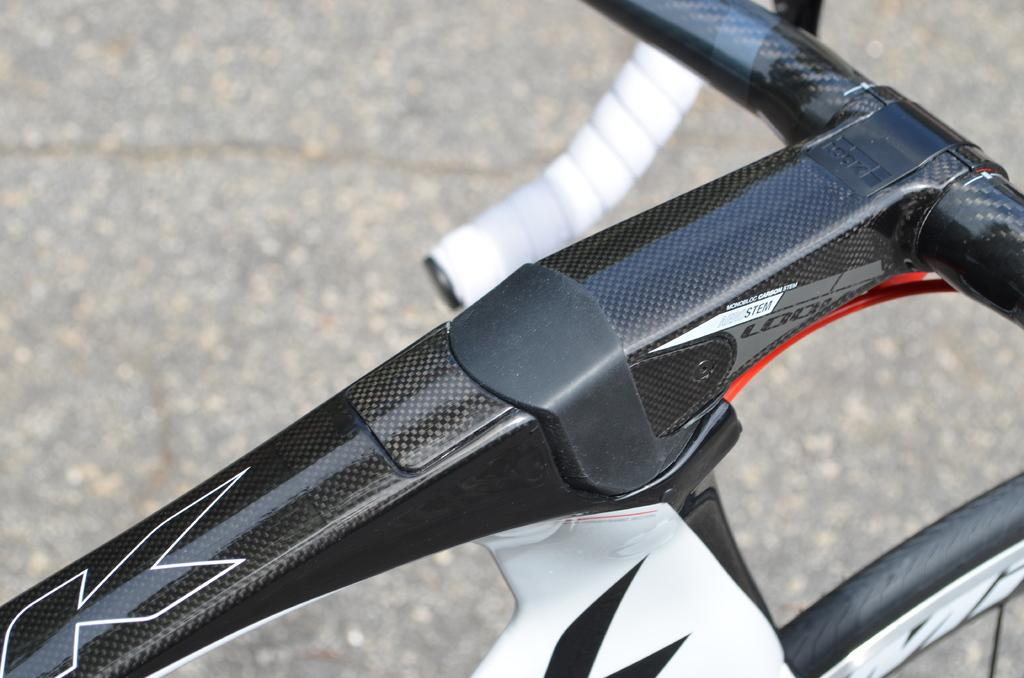Where was the image taken? The image was taken outdoors. What can be seen in the background of the image? There is a road in the background of the image. What is parked on the road at the bottom of the image? A bicycle is parked on the road at the bottom of the image. What type of blood is visible on the chin of the person in the image? There is no person or blood visible in the image; it features a bicycle parked on a road. 